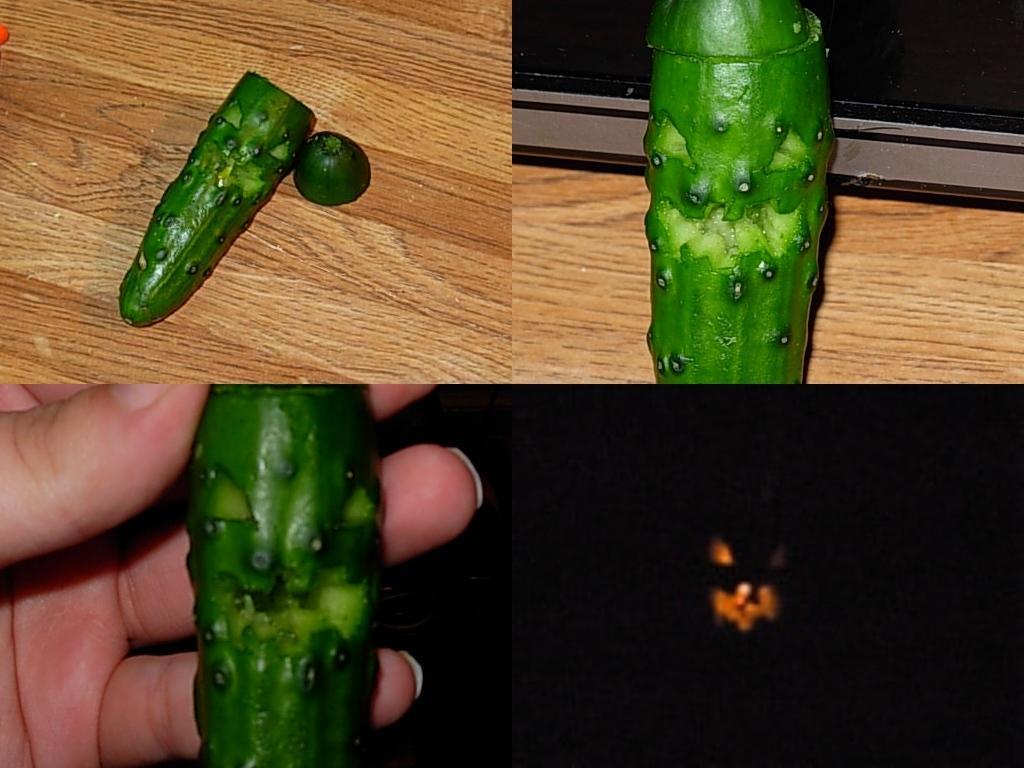Please provide a concise description of this image. The picture is collage of images. In this picture we can see cucumber. At the top two images we can see a wooden object. At the bottom towards left there is a person's hand. At the bottom towards right we can see light, mostly it is dark. 